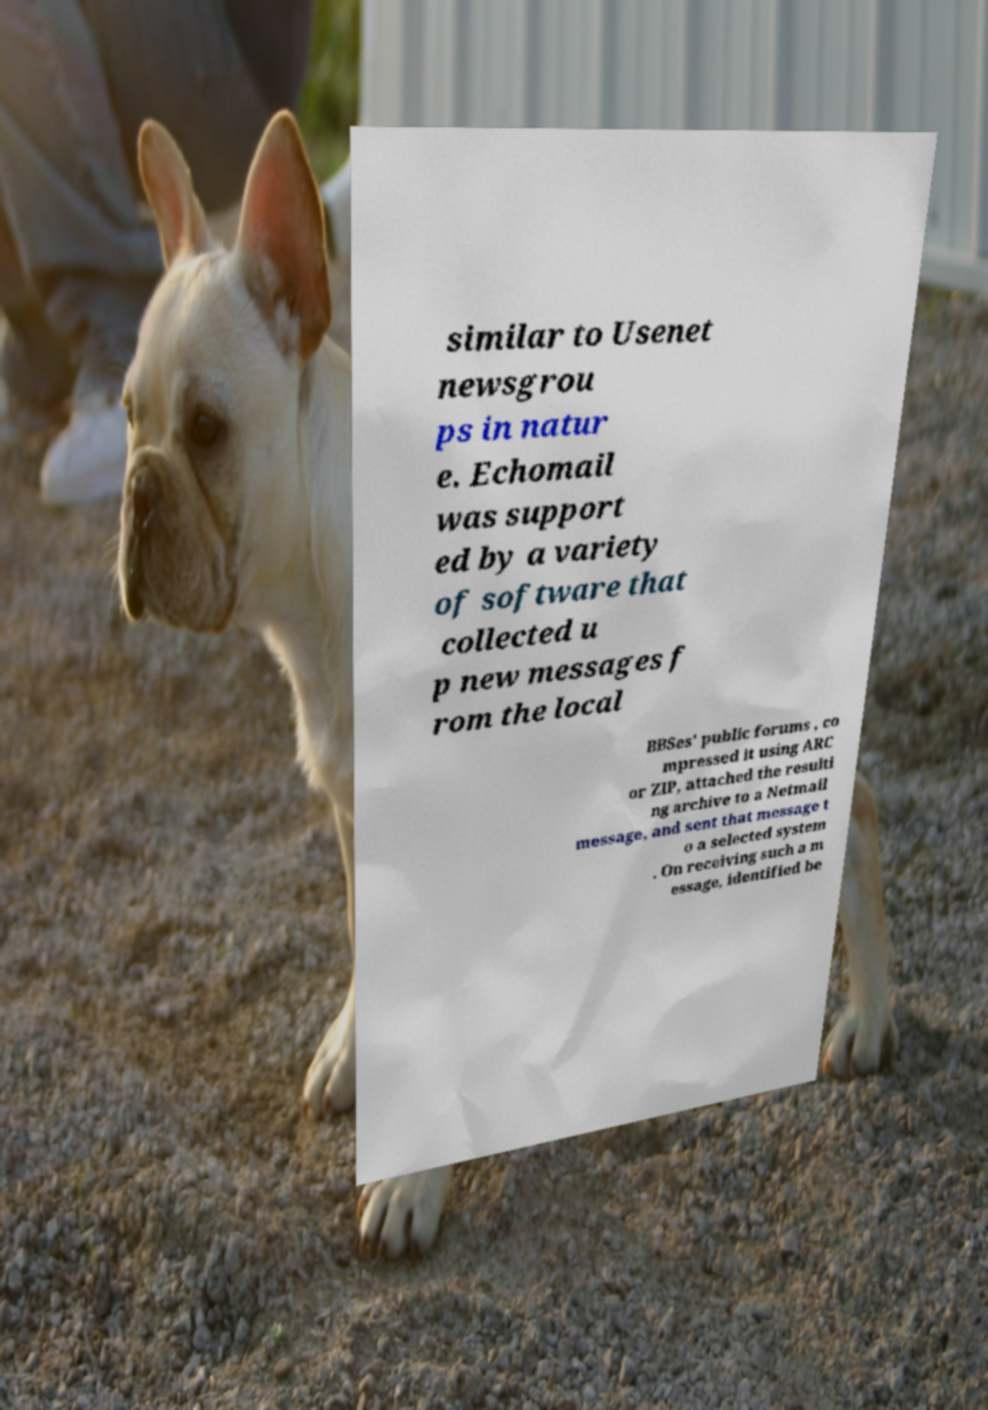Could you assist in decoding the text presented in this image and type it out clearly? similar to Usenet newsgrou ps in natur e. Echomail was support ed by a variety of software that collected u p new messages f rom the local BBSes' public forums , co mpressed it using ARC or ZIP, attached the resulti ng archive to a Netmail message, and sent that message t o a selected system . On receiving such a m essage, identified be 